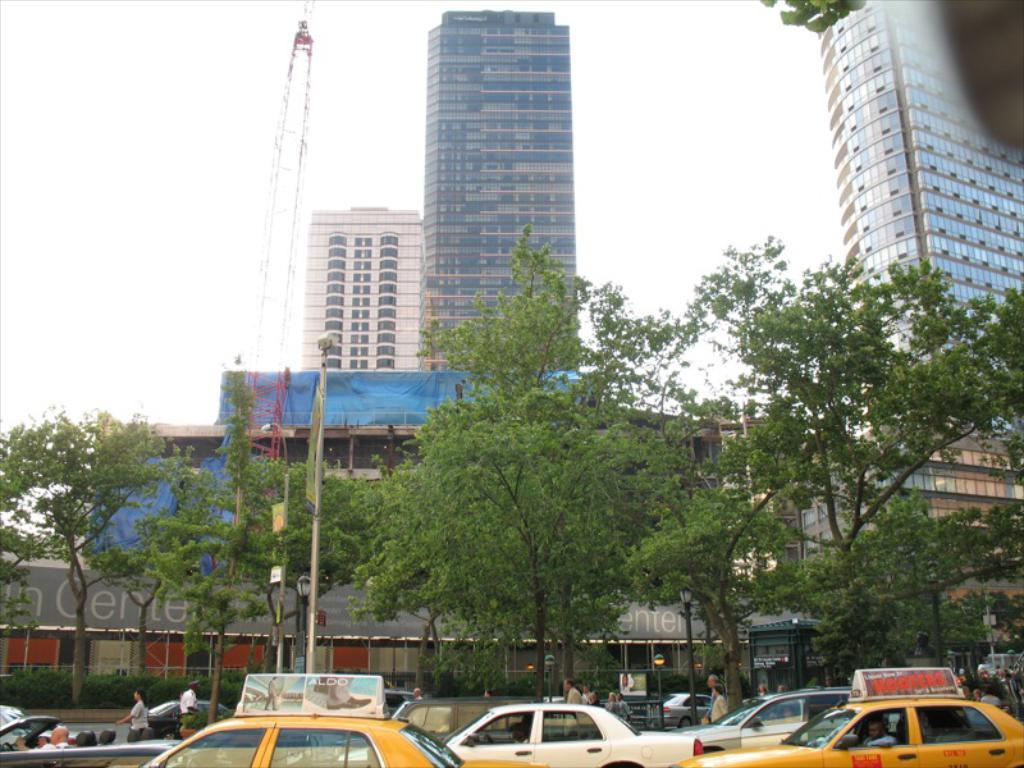Provide a one-sentence caption for the provided image. Two yellow taxi cabs with ads for Hooters and Aldo on their roofs sit in the traffic of a busy city street. 